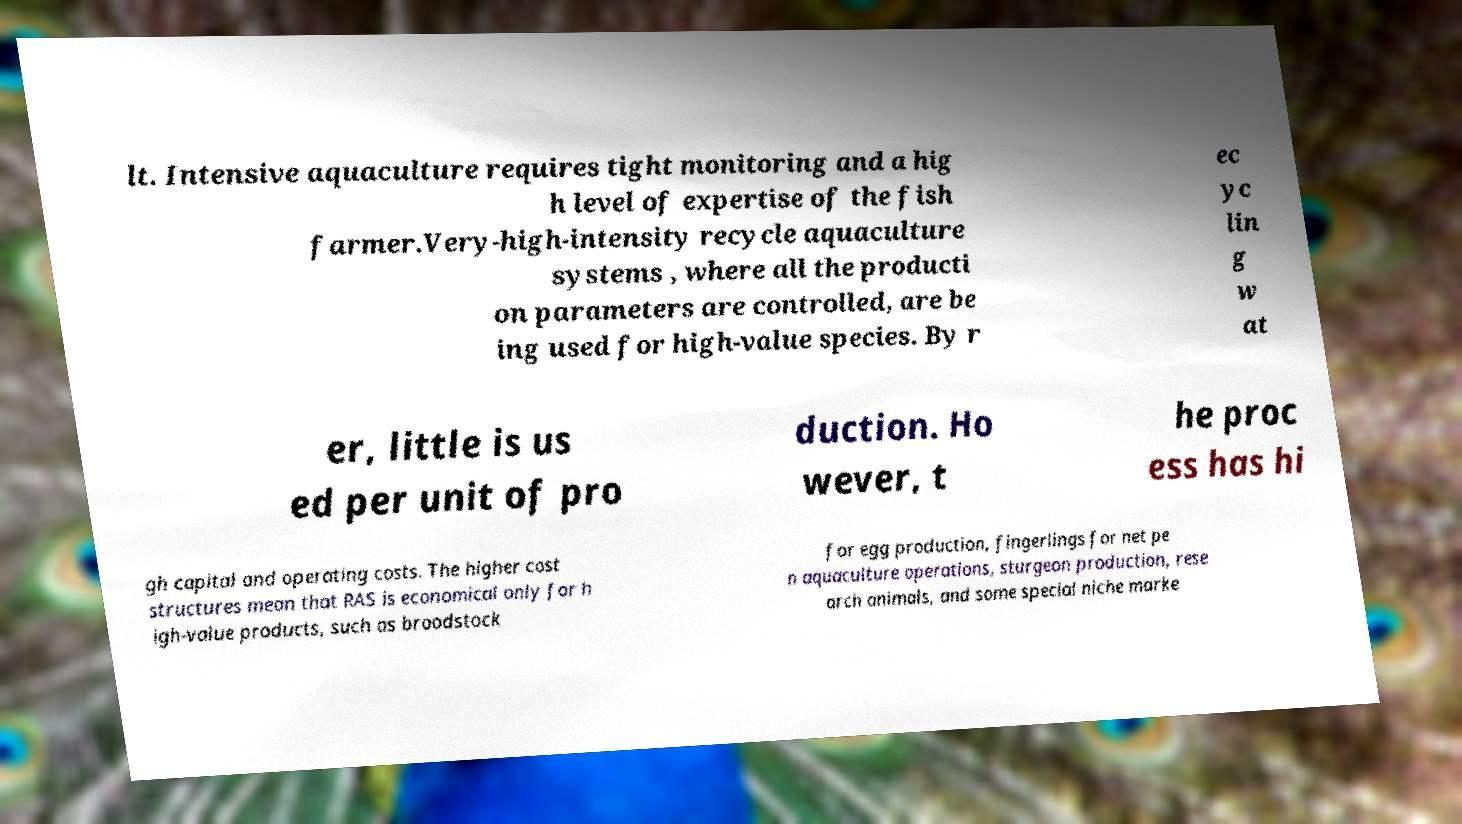I need the written content from this picture converted into text. Can you do that? lt. Intensive aquaculture requires tight monitoring and a hig h level of expertise of the fish farmer.Very-high-intensity recycle aquaculture systems , where all the producti on parameters are controlled, are be ing used for high-value species. By r ec yc lin g w at er, little is us ed per unit of pro duction. Ho wever, t he proc ess has hi gh capital and operating costs. The higher cost structures mean that RAS is economical only for h igh-value products, such as broodstock for egg production, fingerlings for net pe n aquaculture operations, sturgeon production, rese arch animals, and some special niche marke 